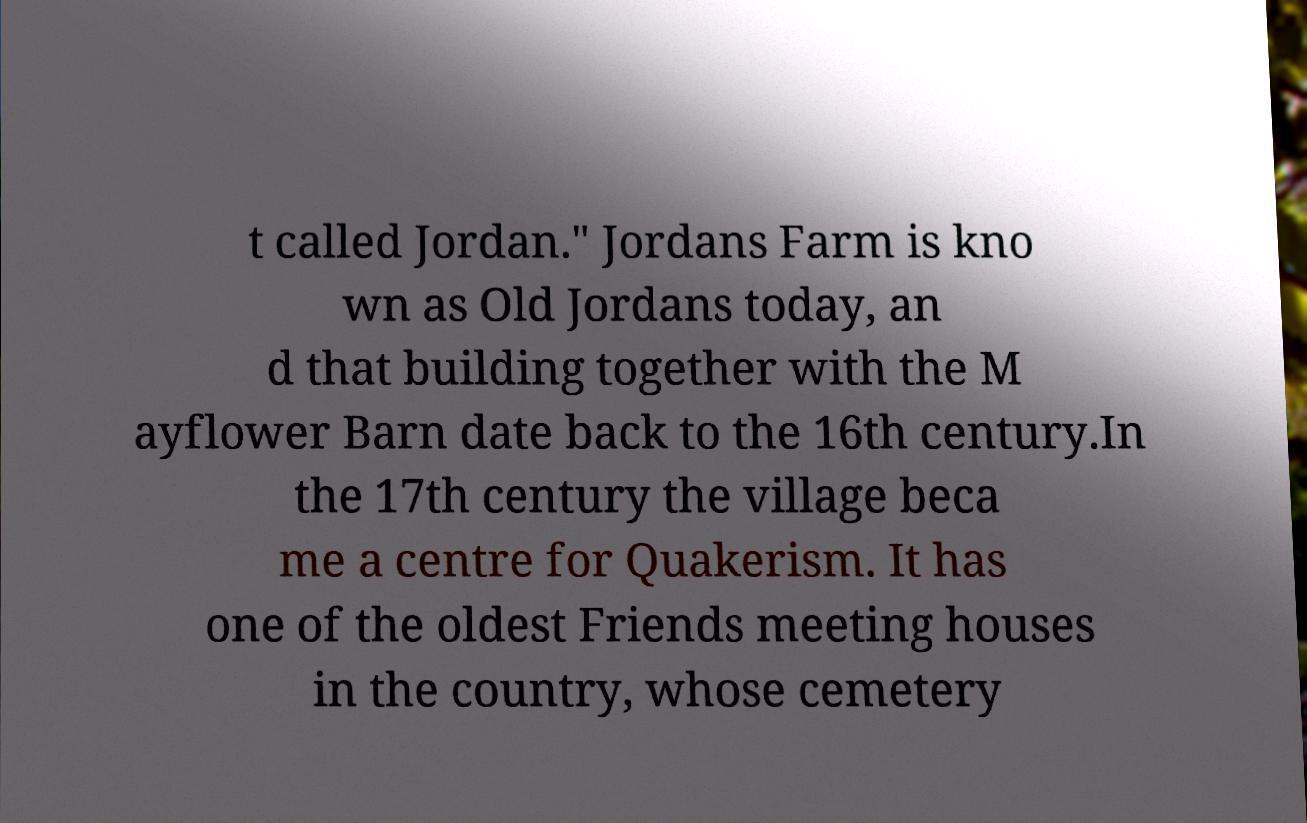I need the written content from this picture converted into text. Can you do that? t called Jordan." Jordans Farm is kno wn as Old Jordans today, an d that building together with the M ayflower Barn date back to the 16th century.In the 17th century the village beca me a centre for Quakerism. It has one of the oldest Friends meeting houses in the country, whose cemetery 